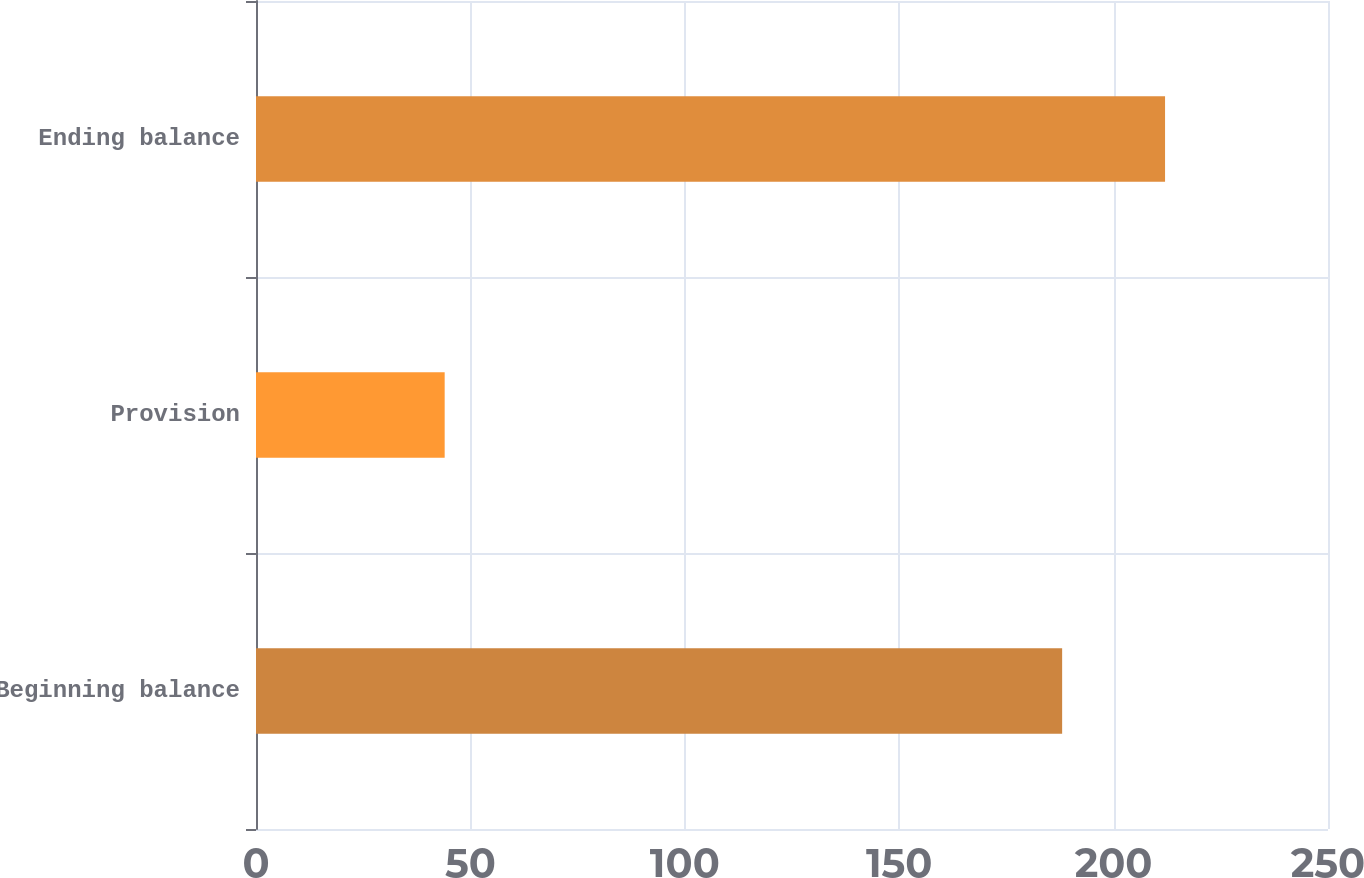Convert chart. <chart><loc_0><loc_0><loc_500><loc_500><bar_chart><fcel>Beginning balance<fcel>Provision<fcel>Ending balance<nl><fcel>188<fcel>44<fcel>212<nl></chart> 